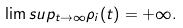<formula> <loc_0><loc_0><loc_500><loc_500>\lim s u p _ { t \to \infty } \rho _ { i } ( t ) = + \infty .</formula> 